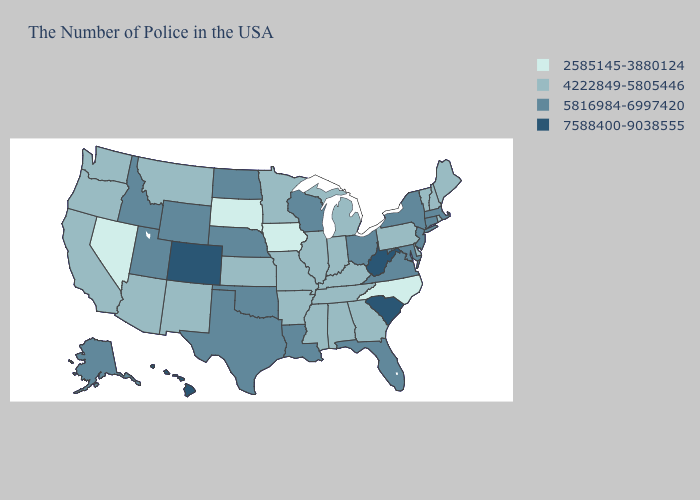Does Indiana have the highest value in the MidWest?
Give a very brief answer. No. Does Maine have a higher value than Nevada?
Write a very short answer. Yes. Does West Virginia have the same value as New Jersey?
Concise answer only. No. Name the states that have a value in the range 7588400-9038555?
Quick response, please. South Carolina, West Virginia, Colorado, Hawaii. Name the states that have a value in the range 4222849-5805446?
Be succinct. Maine, Rhode Island, New Hampshire, Vermont, Delaware, Pennsylvania, Georgia, Michigan, Kentucky, Indiana, Alabama, Tennessee, Illinois, Mississippi, Missouri, Arkansas, Minnesota, Kansas, New Mexico, Montana, Arizona, California, Washington, Oregon. Among the states that border Louisiana , does Texas have the highest value?
Give a very brief answer. Yes. Name the states that have a value in the range 5816984-6997420?
Give a very brief answer. Massachusetts, Connecticut, New York, New Jersey, Maryland, Virginia, Ohio, Florida, Wisconsin, Louisiana, Nebraska, Oklahoma, Texas, North Dakota, Wyoming, Utah, Idaho, Alaska. How many symbols are there in the legend?
Concise answer only. 4. What is the highest value in the USA?
Short answer required. 7588400-9038555. Does the first symbol in the legend represent the smallest category?
Short answer required. Yes. Does Nebraska have the highest value in the MidWest?
Be succinct. Yes. What is the value of Montana?
Short answer required. 4222849-5805446. Does New Jersey have the lowest value in the Northeast?
Write a very short answer. No. What is the value of Minnesota?
Write a very short answer. 4222849-5805446. Which states have the lowest value in the USA?
Keep it brief. North Carolina, Iowa, South Dakota, Nevada. 